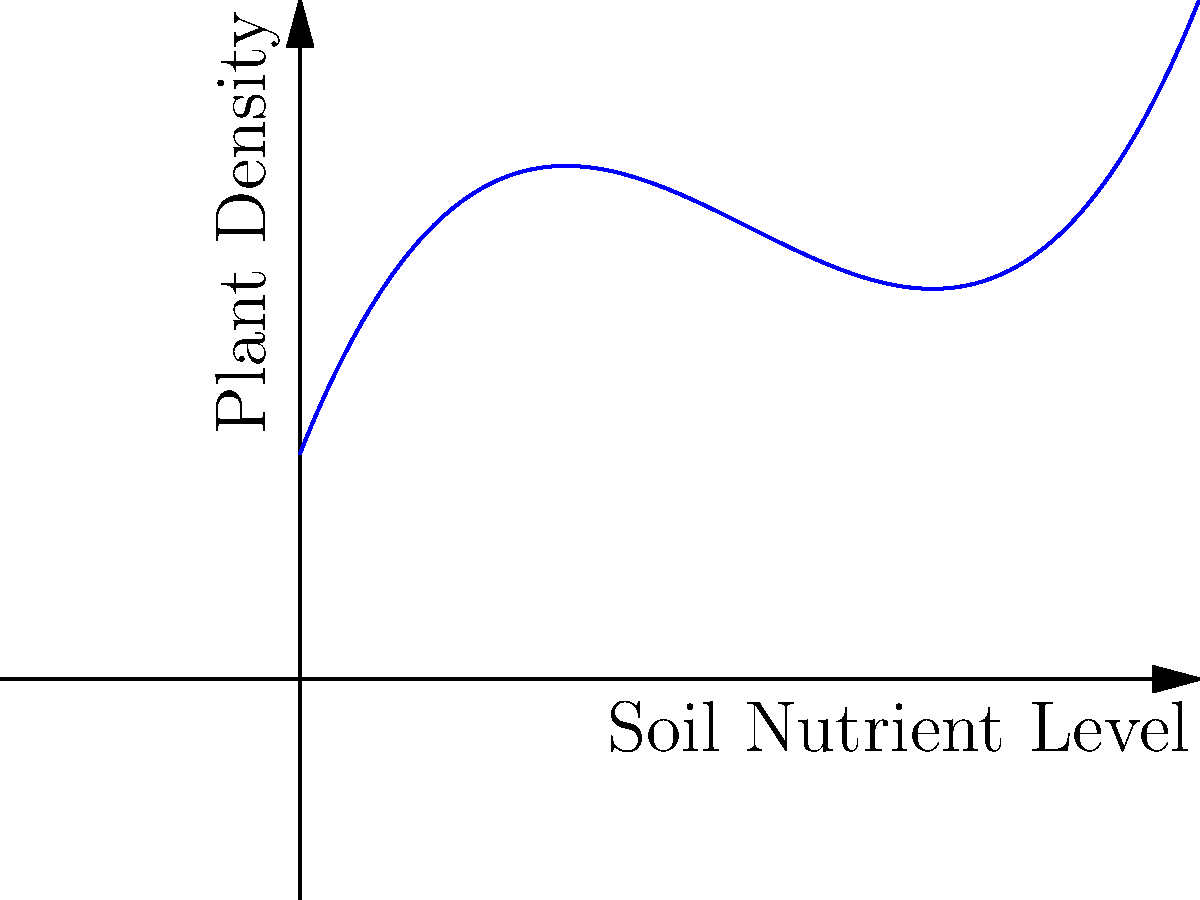The graph represents a polynomial regression curve showing the relationship between soil nutrient levels and plant density in a study area. Points A, B, and C represent specific data points. Based on this information, at which point does the soil nutrient level appear to be most optimal for plant density, and what ecological inference can be drawn from the overall trend? To answer this question, we need to analyze the polynomial regression curve and the given data points:

1. The curve represents the relationship between soil nutrient levels (x-axis) and plant density (y-axis).

2. The shape of the curve is a cubic polynomial, suggesting a complex relationship between the variables.

3. Examining the three points:
   - Point A: (10, 5.5)
   - Point B: (20, 7)
   - Point C: (30, 5)

4. Point B has the highest y-value, indicating the greatest plant density among the three points.

5. The curve reaches its maximum around Point B, suggesting that soil nutrient levels around 20 are most optimal for plant density.

6. The ecological inference from the overall trend:
   - As soil nutrient levels increase from 0 to around 20, plant density increases.
   - Beyond the optimal point (around 20), plant density decreases with further increases in soil nutrients.
   - This suggests that excessive soil nutrients may have a negative impact on plant density, possibly due to factors such as nutrient toxicity or increased competition.
Answer: Point B (20, 7); optimal nutrient level around 20; excessive nutrients may negatively impact plant density. 